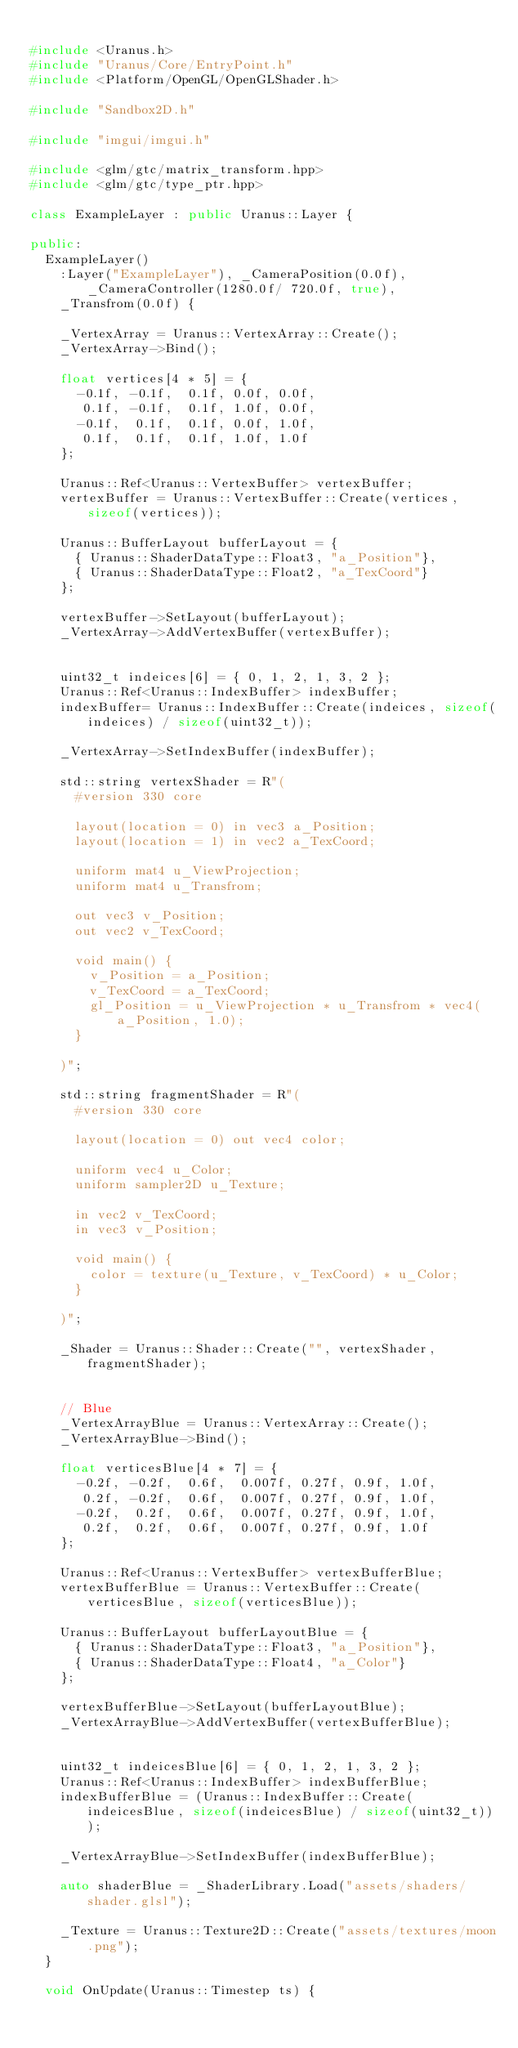<code> <loc_0><loc_0><loc_500><loc_500><_C++_>
#include <Uranus.h>
#include "Uranus/Core/EntryPoint.h"
#include <Platform/OpenGL/OpenGLShader.h>

#include "Sandbox2D.h"

#include "imgui/imgui.h"

#include <glm/gtc/matrix_transform.hpp>
#include <glm/gtc/type_ptr.hpp>

class ExampleLayer : public Uranus::Layer {

public:
	ExampleLayer()
		:Layer("ExampleLayer"), _CameraPosition(0.0f), _CameraController(1280.0f/ 720.0f, true),
		_Transfrom(0.0f) {

		_VertexArray = Uranus::VertexArray::Create();
		_VertexArray->Bind();

		float vertices[4 * 5] = {
			-0.1f, -0.1f,  0.1f, 0.0f, 0.0f,
			 0.1f, -0.1f,  0.1f, 1.0f, 0.0f,
			-0.1f,  0.1f,  0.1f, 0.0f, 1.0f,
			 0.1f,  0.1f,  0.1f, 1.0f, 1.0f
		};

		Uranus::Ref<Uranus::VertexBuffer> vertexBuffer;
		vertexBuffer = Uranus::VertexBuffer::Create(vertices, sizeof(vertices));

		Uranus::BufferLayout bufferLayout = {
			{ Uranus::ShaderDataType::Float3, "a_Position"},
			{ Uranus::ShaderDataType::Float2, "a_TexCoord"}
		};

		vertexBuffer->SetLayout(bufferLayout);
		_VertexArray->AddVertexBuffer(vertexBuffer);


		uint32_t indeices[6] = { 0, 1, 2, 1, 3, 2 };
		Uranus::Ref<Uranus::IndexBuffer> indexBuffer;
		indexBuffer= Uranus::IndexBuffer::Create(indeices, sizeof(indeices) / sizeof(uint32_t));

		_VertexArray->SetIndexBuffer(indexBuffer);

		std::string vertexShader = R"(
			#version 330 core

			layout(location = 0) in vec3 a_Position;
			layout(location = 1) in vec2 a_TexCoord;

			uniform mat4 u_ViewProjection;
			uniform mat4 u_Transfrom;

			out vec3 v_Position;
			out vec2 v_TexCoord;

			void main() {
				v_Position = a_Position;
				v_TexCoord = a_TexCoord;
				gl_Position = u_ViewProjection * u_Transfrom * vec4(a_Position, 1.0);
			}

		)";

		std::string fragmentShader = R"(
			#version 330 core

			layout(location = 0) out vec4 color;

			uniform vec4 u_Color;
			uniform sampler2D u_Texture;
		
			in vec2 v_TexCoord;
			in vec3 v_Position;

			void main() {
				color = texture(u_Texture, v_TexCoord) * u_Color;
			}

		)";

		_Shader = Uranus::Shader::Create("", vertexShader, fragmentShader);


		// Blue
		_VertexArrayBlue = Uranus::VertexArray::Create();
		_VertexArrayBlue->Bind();

		float verticesBlue[4 * 7] = {
			-0.2f, -0.2f,  0.6f,  0.007f, 0.27f, 0.9f, 1.0f,
			 0.2f, -0.2f,  0.6f,  0.007f, 0.27f, 0.9f, 1.0f,
			-0.2f,  0.2f,  0.6f,  0.007f, 0.27f, 0.9f, 1.0f,
			 0.2f,  0.2f,  0.6f,  0.007f, 0.27f, 0.9f, 1.0f
		};
		 
		Uranus::Ref<Uranus::VertexBuffer> vertexBufferBlue;
		vertexBufferBlue = Uranus::VertexBuffer::Create(verticesBlue, sizeof(verticesBlue));

		Uranus::BufferLayout bufferLayoutBlue = {
			{ Uranus::ShaderDataType::Float3, "a_Position"},
			{ Uranus::ShaderDataType::Float4, "a_Color"}
		};

		vertexBufferBlue->SetLayout(bufferLayoutBlue);
		_VertexArrayBlue->AddVertexBuffer(vertexBufferBlue);


		uint32_t indeicesBlue[6] = { 0, 1, 2, 1, 3, 2 };
		Uranus::Ref<Uranus::IndexBuffer> indexBufferBlue;
		indexBufferBlue = (Uranus::IndexBuffer::Create(indeicesBlue, sizeof(indeicesBlue) / sizeof(uint32_t)));

		_VertexArrayBlue->SetIndexBuffer(indexBufferBlue);

		auto shaderBlue = _ShaderLibrary.Load("assets/shaders/shader.glsl");

		_Texture = Uranus::Texture2D::Create("assets/textures/moon.png");
	}

	void OnUpdate(Uranus::Timestep ts) {
</code> 